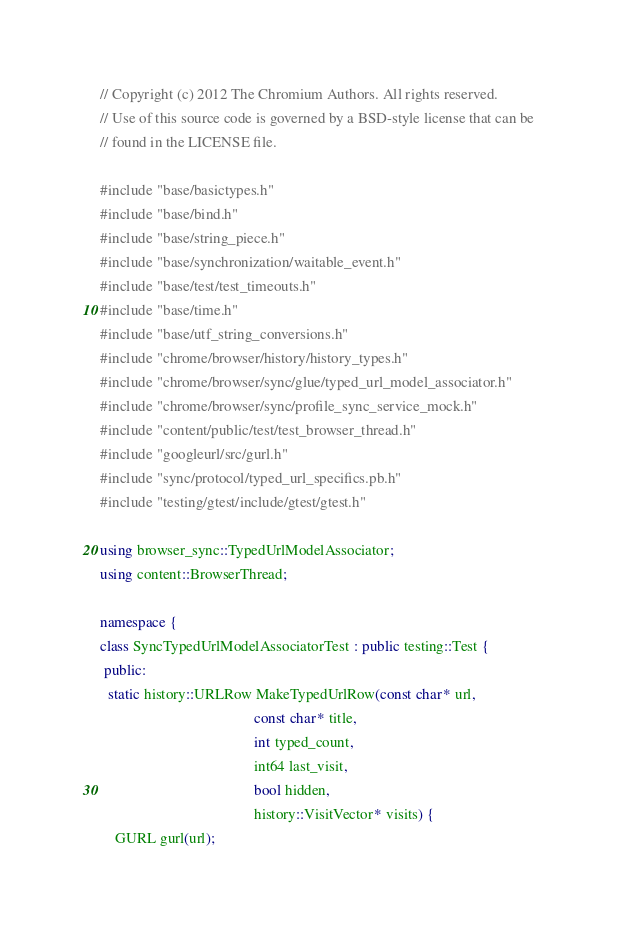<code> <loc_0><loc_0><loc_500><loc_500><_C++_>// Copyright (c) 2012 The Chromium Authors. All rights reserved.
// Use of this source code is governed by a BSD-style license that can be
// found in the LICENSE file.

#include "base/basictypes.h"
#include "base/bind.h"
#include "base/string_piece.h"
#include "base/synchronization/waitable_event.h"
#include "base/test/test_timeouts.h"
#include "base/time.h"
#include "base/utf_string_conversions.h"
#include "chrome/browser/history/history_types.h"
#include "chrome/browser/sync/glue/typed_url_model_associator.h"
#include "chrome/browser/sync/profile_sync_service_mock.h"
#include "content/public/test/test_browser_thread.h"
#include "googleurl/src/gurl.h"
#include "sync/protocol/typed_url_specifics.pb.h"
#include "testing/gtest/include/gtest/gtest.h"

using browser_sync::TypedUrlModelAssociator;
using content::BrowserThread;

namespace {
class SyncTypedUrlModelAssociatorTest : public testing::Test {
 public:
  static history::URLRow MakeTypedUrlRow(const char* url,
                                         const char* title,
                                         int typed_count,
                                         int64 last_visit,
                                         bool hidden,
                                         history::VisitVector* visits) {
    GURL gurl(url);</code> 